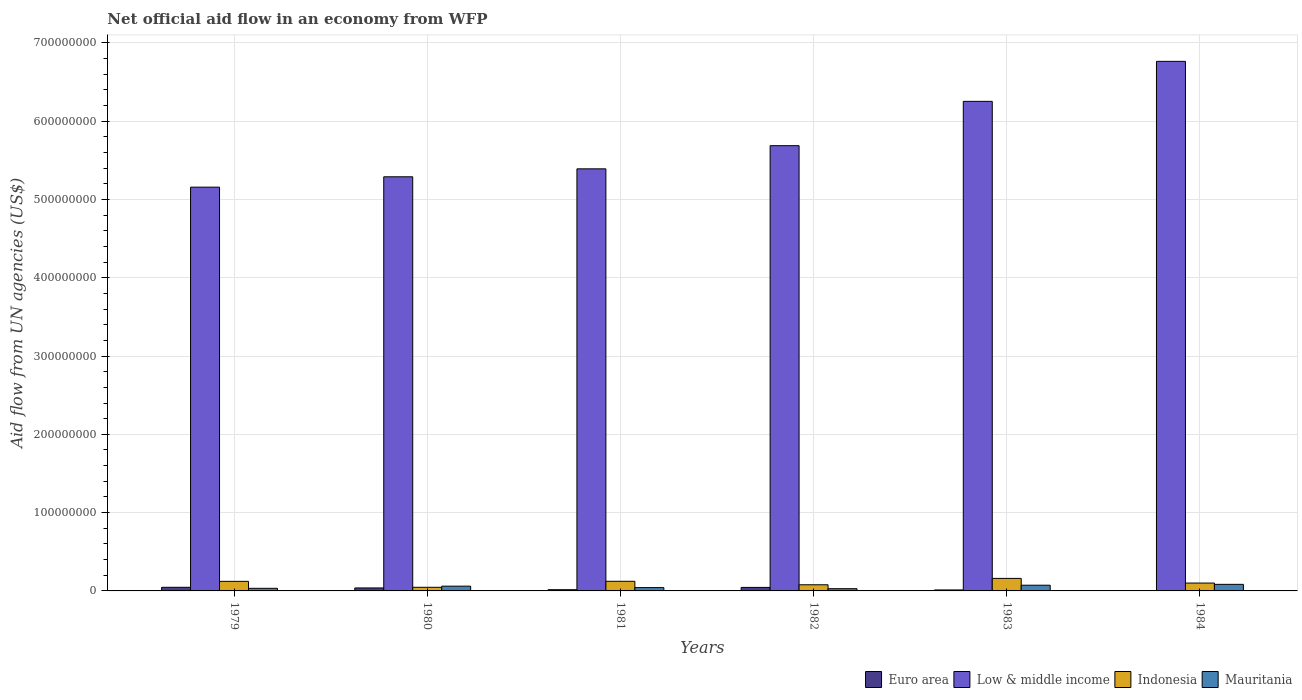How many different coloured bars are there?
Provide a short and direct response. 4. How many groups of bars are there?
Provide a short and direct response. 6. Are the number of bars per tick equal to the number of legend labels?
Keep it short and to the point. Yes. Are the number of bars on each tick of the X-axis equal?
Your answer should be compact. Yes. What is the net official aid flow in Mauritania in 1982?
Ensure brevity in your answer.  2.84e+06. Across all years, what is the maximum net official aid flow in Mauritania?
Give a very brief answer. 8.39e+06. Across all years, what is the minimum net official aid flow in Indonesia?
Keep it short and to the point. 4.63e+06. In which year was the net official aid flow in Euro area minimum?
Make the answer very short. 1984. What is the total net official aid flow in Indonesia in the graph?
Offer a terse response. 6.30e+07. What is the difference between the net official aid flow in Low & middle income in 1979 and that in 1982?
Offer a very short reply. -5.30e+07. What is the difference between the net official aid flow in Euro area in 1979 and the net official aid flow in Mauritania in 1984?
Give a very brief answer. -3.77e+06. What is the average net official aid flow in Euro area per year?
Provide a short and direct response. 2.65e+06. In the year 1983, what is the difference between the net official aid flow in Mauritania and net official aid flow in Low & middle income?
Ensure brevity in your answer.  -6.18e+08. What is the ratio of the net official aid flow in Euro area in 1980 to that in 1982?
Keep it short and to the point. 0.85. Is the net official aid flow in Low & middle income in 1981 less than that in 1982?
Keep it short and to the point. Yes. Is the difference between the net official aid flow in Mauritania in 1979 and 1983 greater than the difference between the net official aid flow in Low & middle income in 1979 and 1983?
Your answer should be very brief. Yes. What is the difference between the highest and the second highest net official aid flow in Indonesia?
Give a very brief answer. 3.68e+06. What is the difference between the highest and the lowest net official aid flow in Mauritania?
Make the answer very short. 5.55e+06. Is the sum of the net official aid flow in Low & middle income in 1979 and 1981 greater than the maximum net official aid flow in Indonesia across all years?
Provide a succinct answer. Yes. Is it the case that in every year, the sum of the net official aid flow in Indonesia and net official aid flow in Mauritania is greater than the sum of net official aid flow in Low & middle income and net official aid flow in Euro area?
Offer a very short reply. No. What does the 4th bar from the right in 1983 represents?
Give a very brief answer. Euro area. Is it the case that in every year, the sum of the net official aid flow in Low & middle income and net official aid flow in Mauritania is greater than the net official aid flow in Euro area?
Offer a terse response. Yes. Are the values on the major ticks of Y-axis written in scientific E-notation?
Ensure brevity in your answer.  No. How many legend labels are there?
Your answer should be very brief. 4. What is the title of the graph?
Keep it short and to the point. Net official aid flow in an economy from WFP. Does "Saudi Arabia" appear as one of the legend labels in the graph?
Offer a very short reply. No. What is the label or title of the X-axis?
Make the answer very short. Years. What is the label or title of the Y-axis?
Provide a short and direct response. Aid flow from UN agencies (US$). What is the Aid flow from UN agencies (US$) of Euro area in 1979?
Your response must be concise. 4.62e+06. What is the Aid flow from UN agencies (US$) in Low & middle income in 1979?
Offer a terse response. 5.16e+08. What is the Aid flow from UN agencies (US$) of Indonesia in 1979?
Make the answer very short. 1.22e+07. What is the Aid flow from UN agencies (US$) of Mauritania in 1979?
Keep it short and to the point. 3.33e+06. What is the Aid flow from UN agencies (US$) of Euro area in 1980?
Ensure brevity in your answer.  3.80e+06. What is the Aid flow from UN agencies (US$) of Low & middle income in 1980?
Keep it short and to the point. 5.29e+08. What is the Aid flow from UN agencies (US$) in Indonesia in 1980?
Offer a terse response. 4.63e+06. What is the Aid flow from UN agencies (US$) of Mauritania in 1980?
Provide a succinct answer. 6.08e+06. What is the Aid flow from UN agencies (US$) of Euro area in 1981?
Make the answer very short. 1.54e+06. What is the Aid flow from UN agencies (US$) in Low & middle income in 1981?
Offer a very short reply. 5.39e+08. What is the Aid flow from UN agencies (US$) in Indonesia in 1981?
Your response must be concise. 1.23e+07. What is the Aid flow from UN agencies (US$) in Mauritania in 1981?
Make the answer very short. 4.24e+06. What is the Aid flow from UN agencies (US$) of Euro area in 1982?
Keep it short and to the point. 4.49e+06. What is the Aid flow from UN agencies (US$) in Low & middle income in 1982?
Keep it short and to the point. 5.69e+08. What is the Aid flow from UN agencies (US$) of Indonesia in 1982?
Ensure brevity in your answer.  7.85e+06. What is the Aid flow from UN agencies (US$) in Mauritania in 1982?
Make the answer very short. 2.84e+06. What is the Aid flow from UN agencies (US$) of Euro area in 1983?
Your answer should be compact. 1.25e+06. What is the Aid flow from UN agencies (US$) in Low & middle income in 1983?
Give a very brief answer. 6.25e+08. What is the Aid flow from UN agencies (US$) in Indonesia in 1983?
Offer a terse response. 1.60e+07. What is the Aid flow from UN agencies (US$) in Mauritania in 1983?
Your answer should be very brief. 7.30e+06. What is the Aid flow from UN agencies (US$) of Low & middle income in 1984?
Offer a very short reply. 6.76e+08. What is the Aid flow from UN agencies (US$) in Indonesia in 1984?
Offer a very short reply. 1.00e+07. What is the Aid flow from UN agencies (US$) in Mauritania in 1984?
Your response must be concise. 8.39e+06. Across all years, what is the maximum Aid flow from UN agencies (US$) of Euro area?
Your answer should be very brief. 4.62e+06. Across all years, what is the maximum Aid flow from UN agencies (US$) in Low & middle income?
Keep it short and to the point. 6.76e+08. Across all years, what is the maximum Aid flow from UN agencies (US$) of Indonesia?
Your answer should be very brief. 1.60e+07. Across all years, what is the maximum Aid flow from UN agencies (US$) of Mauritania?
Ensure brevity in your answer.  8.39e+06. Across all years, what is the minimum Aid flow from UN agencies (US$) in Low & middle income?
Make the answer very short. 5.16e+08. Across all years, what is the minimum Aid flow from UN agencies (US$) in Indonesia?
Your answer should be very brief. 4.63e+06. Across all years, what is the minimum Aid flow from UN agencies (US$) in Mauritania?
Provide a short and direct response. 2.84e+06. What is the total Aid flow from UN agencies (US$) of Euro area in the graph?
Provide a succinct answer. 1.59e+07. What is the total Aid flow from UN agencies (US$) of Low & middle income in the graph?
Your answer should be very brief. 3.45e+09. What is the total Aid flow from UN agencies (US$) in Indonesia in the graph?
Your response must be concise. 6.30e+07. What is the total Aid flow from UN agencies (US$) in Mauritania in the graph?
Ensure brevity in your answer.  3.22e+07. What is the difference between the Aid flow from UN agencies (US$) in Euro area in 1979 and that in 1980?
Keep it short and to the point. 8.20e+05. What is the difference between the Aid flow from UN agencies (US$) of Low & middle income in 1979 and that in 1980?
Your response must be concise. -1.32e+07. What is the difference between the Aid flow from UN agencies (US$) of Indonesia in 1979 and that in 1980?
Your response must be concise. 7.59e+06. What is the difference between the Aid flow from UN agencies (US$) in Mauritania in 1979 and that in 1980?
Offer a very short reply. -2.75e+06. What is the difference between the Aid flow from UN agencies (US$) in Euro area in 1979 and that in 1981?
Your answer should be very brief. 3.08e+06. What is the difference between the Aid flow from UN agencies (US$) in Low & middle income in 1979 and that in 1981?
Make the answer very short. -2.34e+07. What is the difference between the Aid flow from UN agencies (US$) in Indonesia in 1979 and that in 1981?
Give a very brief answer. -9.00e+04. What is the difference between the Aid flow from UN agencies (US$) in Mauritania in 1979 and that in 1981?
Provide a succinct answer. -9.10e+05. What is the difference between the Aid flow from UN agencies (US$) of Euro area in 1979 and that in 1982?
Ensure brevity in your answer.  1.30e+05. What is the difference between the Aid flow from UN agencies (US$) of Low & middle income in 1979 and that in 1982?
Your answer should be very brief. -5.30e+07. What is the difference between the Aid flow from UN agencies (US$) of Indonesia in 1979 and that in 1982?
Make the answer very short. 4.37e+06. What is the difference between the Aid flow from UN agencies (US$) of Mauritania in 1979 and that in 1982?
Offer a very short reply. 4.90e+05. What is the difference between the Aid flow from UN agencies (US$) of Euro area in 1979 and that in 1983?
Your answer should be very brief. 3.37e+06. What is the difference between the Aid flow from UN agencies (US$) in Low & middle income in 1979 and that in 1983?
Ensure brevity in your answer.  -1.10e+08. What is the difference between the Aid flow from UN agencies (US$) of Indonesia in 1979 and that in 1983?
Your answer should be very brief. -3.77e+06. What is the difference between the Aid flow from UN agencies (US$) in Mauritania in 1979 and that in 1983?
Provide a succinct answer. -3.97e+06. What is the difference between the Aid flow from UN agencies (US$) in Euro area in 1979 and that in 1984?
Provide a short and direct response. 4.40e+06. What is the difference between the Aid flow from UN agencies (US$) in Low & middle income in 1979 and that in 1984?
Your answer should be very brief. -1.61e+08. What is the difference between the Aid flow from UN agencies (US$) in Indonesia in 1979 and that in 1984?
Give a very brief answer. 2.17e+06. What is the difference between the Aid flow from UN agencies (US$) in Mauritania in 1979 and that in 1984?
Ensure brevity in your answer.  -5.06e+06. What is the difference between the Aid flow from UN agencies (US$) in Euro area in 1980 and that in 1981?
Keep it short and to the point. 2.26e+06. What is the difference between the Aid flow from UN agencies (US$) of Low & middle income in 1980 and that in 1981?
Give a very brief answer. -1.02e+07. What is the difference between the Aid flow from UN agencies (US$) of Indonesia in 1980 and that in 1981?
Ensure brevity in your answer.  -7.68e+06. What is the difference between the Aid flow from UN agencies (US$) of Mauritania in 1980 and that in 1981?
Your answer should be very brief. 1.84e+06. What is the difference between the Aid flow from UN agencies (US$) in Euro area in 1980 and that in 1982?
Offer a very short reply. -6.90e+05. What is the difference between the Aid flow from UN agencies (US$) in Low & middle income in 1980 and that in 1982?
Give a very brief answer. -3.97e+07. What is the difference between the Aid flow from UN agencies (US$) of Indonesia in 1980 and that in 1982?
Your response must be concise. -3.22e+06. What is the difference between the Aid flow from UN agencies (US$) of Mauritania in 1980 and that in 1982?
Ensure brevity in your answer.  3.24e+06. What is the difference between the Aid flow from UN agencies (US$) in Euro area in 1980 and that in 1983?
Make the answer very short. 2.55e+06. What is the difference between the Aid flow from UN agencies (US$) in Low & middle income in 1980 and that in 1983?
Your response must be concise. -9.63e+07. What is the difference between the Aid flow from UN agencies (US$) in Indonesia in 1980 and that in 1983?
Offer a very short reply. -1.14e+07. What is the difference between the Aid flow from UN agencies (US$) in Mauritania in 1980 and that in 1983?
Ensure brevity in your answer.  -1.22e+06. What is the difference between the Aid flow from UN agencies (US$) of Euro area in 1980 and that in 1984?
Ensure brevity in your answer.  3.58e+06. What is the difference between the Aid flow from UN agencies (US$) of Low & middle income in 1980 and that in 1984?
Your answer should be very brief. -1.47e+08. What is the difference between the Aid flow from UN agencies (US$) of Indonesia in 1980 and that in 1984?
Your answer should be compact. -5.42e+06. What is the difference between the Aid flow from UN agencies (US$) in Mauritania in 1980 and that in 1984?
Offer a very short reply. -2.31e+06. What is the difference between the Aid flow from UN agencies (US$) in Euro area in 1981 and that in 1982?
Keep it short and to the point. -2.95e+06. What is the difference between the Aid flow from UN agencies (US$) of Low & middle income in 1981 and that in 1982?
Keep it short and to the point. -2.96e+07. What is the difference between the Aid flow from UN agencies (US$) of Indonesia in 1981 and that in 1982?
Your answer should be compact. 4.46e+06. What is the difference between the Aid flow from UN agencies (US$) of Mauritania in 1981 and that in 1982?
Provide a short and direct response. 1.40e+06. What is the difference between the Aid flow from UN agencies (US$) in Euro area in 1981 and that in 1983?
Your answer should be very brief. 2.90e+05. What is the difference between the Aid flow from UN agencies (US$) in Low & middle income in 1981 and that in 1983?
Give a very brief answer. -8.62e+07. What is the difference between the Aid flow from UN agencies (US$) of Indonesia in 1981 and that in 1983?
Ensure brevity in your answer.  -3.68e+06. What is the difference between the Aid flow from UN agencies (US$) of Mauritania in 1981 and that in 1983?
Your response must be concise. -3.06e+06. What is the difference between the Aid flow from UN agencies (US$) in Euro area in 1981 and that in 1984?
Your answer should be very brief. 1.32e+06. What is the difference between the Aid flow from UN agencies (US$) in Low & middle income in 1981 and that in 1984?
Offer a terse response. -1.37e+08. What is the difference between the Aid flow from UN agencies (US$) in Indonesia in 1981 and that in 1984?
Your answer should be very brief. 2.26e+06. What is the difference between the Aid flow from UN agencies (US$) in Mauritania in 1981 and that in 1984?
Your response must be concise. -4.15e+06. What is the difference between the Aid flow from UN agencies (US$) of Euro area in 1982 and that in 1983?
Ensure brevity in your answer.  3.24e+06. What is the difference between the Aid flow from UN agencies (US$) of Low & middle income in 1982 and that in 1983?
Your answer should be very brief. -5.66e+07. What is the difference between the Aid flow from UN agencies (US$) in Indonesia in 1982 and that in 1983?
Provide a succinct answer. -8.14e+06. What is the difference between the Aid flow from UN agencies (US$) of Mauritania in 1982 and that in 1983?
Offer a very short reply. -4.46e+06. What is the difference between the Aid flow from UN agencies (US$) in Euro area in 1982 and that in 1984?
Give a very brief answer. 4.27e+06. What is the difference between the Aid flow from UN agencies (US$) of Low & middle income in 1982 and that in 1984?
Your answer should be very brief. -1.08e+08. What is the difference between the Aid flow from UN agencies (US$) in Indonesia in 1982 and that in 1984?
Keep it short and to the point. -2.20e+06. What is the difference between the Aid flow from UN agencies (US$) in Mauritania in 1982 and that in 1984?
Give a very brief answer. -5.55e+06. What is the difference between the Aid flow from UN agencies (US$) of Euro area in 1983 and that in 1984?
Your answer should be compact. 1.03e+06. What is the difference between the Aid flow from UN agencies (US$) of Low & middle income in 1983 and that in 1984?
Your answer should be compact. -5.11e+07. What is the difference between the Aid flow from UN agencies (US$) of Indonesia in 1983 and that in 1984?
Offer a very short reply. 5.94e+06. What is the difference between the Aid flow from UN agencies (US$) of Mauritania in 1983 and that in 1984?
Provide a succinct answer. -1.09e+06. What is the difference between the Aid flow from UN agencies (US$) in Euro area in 1979 and the Aid flow from UN agencies (US$) in Low & middle income in 1980?
Give a very brief answer. -5.24e+08. What is the difference between the Aid flow from UN agencies (US$) of Euro area in 1979 and the Aid flow from UN agencies (US$) of Indonesia in 1980?
Your answer should be very brief. -10000. What is the difference between the Aid flow from UN agencies (US$) in Euro area in 1979 and the Aid flow from UN agencies (US$) in Mauritania in 1980?
Ensure brevity in your answer.  -1.46e+06. What is the difference between the Aid flow from UN agencies (US$) of Low & middle income in 1979 and the Aid flow from UN agencies (US$) of Indonesia in 1980?
Give a very brief answer. 5.11e+08. What is the difference between the Aid flow from UN agencies (US$) of Low & middle income in 1979 and the Aid flow from UN agencies (US$) of Mauritania in 1980?
Your answer should be compact. 5.10e+08. What is the difference between the Aid flow from UN agencies (US$) in Indonesia in 1979 and the Aid flow from UN agencies (US$) in Mauritania in 1980?
Your answer should be very brief. 6.14e+06. What is the difference between the Aid flow from UN agencies (US$) of Euro area in 1979 and the Aid flow from UN agencies (US$) of Low & middle income in 1981?
Ensure brevity in your answer.  -5.34e+08. What is the difference between the Aid flow from UN agencies (US$) in Euro area in 1979 and the Aid flow from UN agencies (US$) in Indonesia in 1981?
Provide a succinct answer. -7.69e+06. What is the difference between the Aid flow from UN agencies (US$) in Euro area in 1979 and the Aid flow from UN agencies (US$) in Mauritania in 1981?
Provide a succinct answer. 3.80e+05. What is the difference between the Aid flow from UN agencies (US$) of Low & middle income in 1979 and the Aid flow from UN agencies (US$) of Indonesia in 1981?
Provide a short and direct response. 5.03e+08. What is the difference between the Aid flow from UN agencies (US$) in Low & middle income in 1979 and the Aid flow from UN agencies (US$) in Mauritania in 1981?
Your answer should be very brief. 5.11e+08. What is the difference between the Aid flow from UN agencies (US$) in Indonesia in 1979 and the Aid flow from UN agencies (US$) in Mauritania in 1981?
Your answer should be very brief. 7.98e+06. What is the difference between the Aid flow from UN agencies (US$) of Euro area in 1979 and the Aid flow from UN agencies (US$) of Low & middle income in 1982?
Keep it short and to the point. -5.64e+08. What is the difference between the Aid flow from UN agencies (US$) in Euro area in 1979 and the Aid flow from UN agencies (US$) in Indonesia in 1982?
Your answer should be very brief. -3.23e+06. What is the difference between the Aid flow from UN agencies (US$) in Euro area in 1979 and the Aid flow from UN agencies (US$) in Mauritania in 1982?
Your answer should be compact. 1.78e+06. What is the difference between the Aid flow from UN agencies (US$) in Low & middle income in 1979 and the Aid flow from UN agencies (US$) in Indonesia in 1982?
Give a very brief answer. 5.08e+08. What is the difference between the Aid flow from UN agencies (US$) in Low & middle income in 1979 and the Aid flow from UN agencies (US$) in Mauritania in 1982?
Ensure brevity in your answer.  5.13e+08. What is the difference between the Aid flow from UN agencies (US$) in Indonesia in 1979 and the Aid flow from UN agencies (US$) in Mauritania in 1982?
Give a very brief answer. 9.38e+06. What is the difference between the Aid flow from UN agencies (US$) of Euro area in 1979 and the Aid flow from UN agencies (US$) of Low & middle income in 1983?
Keep it short and to the point. -6.21e+08. What is the difference between the Aid flow from UN agencies (US$) in Euro area in 1979 and the Aid flow from UN agencies (US$) in Indonesia in 1983?
Your answer should be compact. -1.14e+07. What is the difference between the Aid flow from UN agencies (US$) in Euro area in 1979 and the Aid flow from UN agencies (US$) in Mauritania in 1983?
Keep it short and to the point. -2.68e+06. What is the difference between the Aid flow from UN agencies (US$) of Low & middle income in 1979 and the Aid flow from UN agencies (US$) of Indonesia in 1983?
Provide a short and direct response. 5.00e+08. What is the difference between the Aid flow from UN agencies (US$) in Low & middle income in 1979 and the Aid flow from UN agencies (US$) in Mauritania in 1983?
Offer a terse response. 5.08e+08. What is the difference between the Aid flow from UN agencies (US$) of Indonesia in 1979 and the Aid flow from UN agencies (US$) of Mauritania in 1983?
Provide a succinct answer. 4.92e+06. What is the difference between the Aid flow from UN agencies (US$) in Euro area in 1979 and the Aid flow from UN agencies (US$) in Low & middle income in 1984?
Ensure brevity in your answer.  -6.72e+08. What is the difference between the Aid flow from UN agencies (US$) of Euro area in 1979 and the Aid flow from UN agencies (US$) of Indonesia in 1984?
Your answer should be compact. -5.43e+06. What is the difference between the Aid flow from UN agencies (US$) in Euro area in 1979 and the Aid flow from UN agencies (US$) in Mauritania in 1984?
Your answer should be very brief. -3.77e+06. What is the difference between the Aid flow from UN agencies (US$) in Low & middle income in 1979 and the Aid flow from UN agencies (US$) in Indonesia in 1984?
Your response must be concise. 5.06e+08. What is the difference between the Aid flow from UN agencies (US$) of Low & middle income in 1979 and the Aid flow from UN agencies (US$) of Mauritania in 1984?
Ensure brevity in your answer.  5.07e+08. What is the difference between the Aid flow from UN agencies (US$) of Indonesia in 1979 and the Aid flow from UN agencies (US$) of Mauritania in 1984?
Provide a short and direct response. 3.83e+06. What is the difference between the Aid flow from UN agencies (US$) in Euro area in 1980 and the Aid flow from UN agencies (US$) in Low & middle income in 1981?
Make the answer very short. -5.35e+08. What is the difference between the Aid flow from UN agencies (US$) in Euro area in 1980 and the Aid flow from UN agencies (US$) in Indonesia in 1981?
Give a very brief answer. -8.51e+06. What is the difference between the Aid flow from UN agencies (US$) of Euro area in 1980 and the Aid flow from UN agencies (US$) of Mauritania in 1981?
Give a very brief answer. -4.40e+05. What is the difference between the Aid flow from UN agencies (US$) of Low & middle income in 1980 and the Aid flow from UN agencies (US$) of Indonesia in 1981?
Offer a very short reply. 5.17e+08. What is the difference between the Aid flow from UN agencies (US$) of Low & middle income in 1980 and the Aid flow from UN agencies (US$) of Mauritania in 1981?
Make the answer very short. 5.25e+08. What is the difference between the Aid flow from UN agencies (US$) in Euro area in 1980 and the Aid flow from UN agencies (US$) in Low & middle income in 1982?
Your response must be concise. -5.65e+08. What is the difference between the Aid flow from UN agencies (US$) in Euro area in 1980 and the Aid flow from UN agencies (US$) in Indonesia in 1982?
Provide a succinct answer. -4.05e+06. What is the difference between the Aid flow from UN agencies (US$) in Euro area in 1980 and the Aid flow from UN agencies (US$) in Mauritania in 1982?
Provide a succinct answer. 9.60e+05. What is the difference between the Aid flow from UN agencies (US$) in Low & middle income in 1980 and the Aid flow from UN agencies (US$) in Indonesia in 1982?
Keep it short and to the point. 5.21e+08. What is the difference between the Aid flow from UN agencies (US$) in Low & middle income in 1980 and the Aid flow from UN agencies (US$) in Mauritania in 1982?
Ensure brevity in your answer.  5.26e+08. What is the difference between the Aid flow from UN agencies (US$) in Indonesia in 1980 and the Aid flow from UN agencies (US$) in Mauritania in 1982?
Make the answer very short. 1.79e+06. What is the difference between the Aid flow from UN agencies (US$) of Euro area in 1980 and the Aid flow from UN agencies (US$) of Low & middle income in 1983?
Your answer should be compact. -6.21e+08. What is the difference between the Aid flow from UN agencies (US$) in Euro area in 1980 and the Aid flow from UN agencies (US$) in Indonesia in 1983?
Your answer should be compact. -1.22e+07. What is the difference between the Aid flow from UN agencies (US$) in Euro area in 1980 and the Aid flow from UN agencies (US$) in Mauritania in 1983?
Give a very brief answer. -3.50e+06. What is the difference between the Aid flow from UN agencies (US$) of Low & middle income in 1980 and the Aid flow from UN agencies (US$) of Indonesia in 1983?
Make the answer very short. 5.13e+08. What is the difference between the Aid flow from UN agencies (US$) in Low & middle income in 1980 and the Aid flow from UN agencies (US$) in Mauritania in 1983?
Your response must be concise. 5.22e+08. What is the difference between the Aid flow from UN agencies (US$) in Indonesia in 1980 and the Aid flow from UN agencies (US$) in Mauritania in 1983?
Offer a terse response. -2.67e+06. What is the difference between the Aid flow from UN agencies (US$) of Euro area in 1980 and the Aid flow from UN agencies (US$) of Low & middle income in 1984?
Ensure brevity in your answer.  -6.73e+08. What is the difference between the Aid flow from UN agencies (US$) of Euro area in 1980 and the Aid flow from UN agencies (US$) of Indonesia in 1984?
Your answer should be compact. -6.25e+06. What is the difference between the Aid flow from UN agencies (US$) in Euro area in 1980 and the Aid flow from UN agencies (US$) in Mauritania in 1984?
Give a very brief answer. -4.59e+06. What is the difference between the Aid flow from UN agencies (US$) in Low & middle income in 1980 and the Aid flow from UN agencies (US$) in Indonesia in 1984?
Your answer should be compact. 5.19e+08. What is the difference between the Aid flow from UN agencies (US$) in Low & middle income in 1980 and the Aid flow from UN agencies (US$) in Mauritania in 1984?
Offer a very short reply. 5.21e+08. What is the difference between the Aid flow from UN agencies (US$) in Indonesia in 1980 and the Aid flow from UN agencies (US$) in Mauritania in 1984?
Give a very brief answer. -3.76e+06. What is the difference between the Aid flow from UN agencies (US$) of Euro area in 1981 and the Aid flow from UN agencies (US$) of Low & middle income in 1982?
Offer a terse response. -5.67e+08. What is the difference between the Aid flow from UN agencies (US$) of Euro area in 1981 and the Aid flow from UN agencies (US$) of Indonesia in 1982?
Offer a terse response. -6.31e+06. What is the difference between the Aid flow from UN agencies (US$) of Euro area in 1981 and the Aid flow from UN agencies (US$) of Mauritania in 1982?
Provide a succinct answer. -1.30e+06. What is the difference between the Aid flow from UN agencies (US$) of Low & middle income in 1981 and the Aid flow from UN agencies (US$) of Indonesia in 1982?
Give a very brief answer. 5.31e+08. What is the difference between the Aid flow from UN agencies (US$) of Low & middle income in 1981 and the Aid flow from UN agencies (US$) of Mauritania in 1982?
Keep it short and to the point. 5.36e+08. What is the difference between the Aid flow from UN agencies (US$) of Indonesia in 1981 and the Aid flow from UN agencies (US$) of Mauritania in 1982?
Offer a terse response. 9.47e+06. What is the difference between the Aid flow from UN agencies (US$) of Euro area in 1981 and the Aid flow from UN agencies (US$) of Low & middle income in 1983?
Make the answer very short. -6.24e+08. What is the difference between the Aid flow from UN agencies (US$) of Euro area in 1981 and the Aid flow from UN agencies (US$) of Indonesia in 1983?
Ensure brevity in your answer.  -1.44e+07. What is the difference between the Aid flow from UN agencies (US$) in Euro area in 1981 and the Aid flow from UN agencies (US$) in Mauritania in 1983?
Make the answer very short. -5.76e+06. What is the difference between the Aid flow from UN agencies (US$) of Low & middle income in 1981 and the Aid flow from UN agencies (US$) of Indonesia in 1983?
Your answer should be very brief. 5.23e+08. What is the difference between the Aid flow from UN agencies (US$) in Low & middle income in 1981 and the Aid flow from UN agencies (US$) in Mauritania in 1983?
Give a very brief answer. 5.32e+08. What is the difference between the Aid flow from UN agencies (US$) of Indonesia in 1981 and the Aid flow from UN agencies (US$) of Mauritania in 1983?
Keep it short and to the point. 5.01e+06. What is the difference between the Aid flow from UN agencies (US$) in Euro area in 1981 and the Aid flow from UN agencies (US$) in Low & middle income in 1984?
Keep it short and to the point. -6.75e+08. What is the difference between the Aid flow from UN agencies (US$) of Euro area in 1981 and the Aid flow from UN agencies (US$) of Indonesia in 1984?
Your answer should be compact. -8.51e+06. What is the difference between the Aid flow from UN agencies (US$) in Euro area in 1981 and the Aid flow from UN agencies (US$) in Mauritania in 1984?
Your answer should be compact. -6.85e+06. What is the difference between the Aid flow from UN agencies (US$) of Low & middle income in 1981 and the Aid flow from UN agencies (US$) of Indonesia in 1984?
Ensure brevity in your answer.  5.29e+08. What is the difference between the Aid flow from UN agencies (US$) of Low & middle income in 1981 and the Aid flow from UN agencies (US$) of Mauritania in 1984?
Your answer should be compact. 5.31e+08. What is the difference between the Aid flow from UN agencies (US$) of Indonesia in 1981 and the Aid flow from UN agencies (US$) of Mauritania in 1984?
Your answer should be very brief. 3.92e+06. What is the difference between the Aid flow from UN agencies (US$) of Euro area in 1982 and the Aid flow from UN agencies (US$) of Low & middle income in 1983?
Offer a terse response. -6.21e+08. What is the difference between the Aid flow from UN agencies (US$) of Euro area in 1982 and the Aid flow from UN agencies (US$) of Indonesia in 1983?
Keep it short and to the point. -1.15e+07. What is the difference between the Aid flow from UN agencies (US$) of Euro area in 1982 and the Aid flow from UN agencies (US$) of Mauritania in 1983?
Offer a very short reply. -2.81e+06. What is the difference between the Aid flow from UN agencies (US$) in Low & middle income in 1982 and the Aid flow from UN agencies (US$) in Indonesia in 1983?
Your response must be concise. 5.53e+08. What is the difference between the Aid flow from UN agencies (US$) of Low & middle income in 1982 and the Aid flow from UN agencies (US$) of Mauritania in 1983?
Your answer should be compact. 5.61e+08. What is the difference between the Aid flow from UN agencies (US$) in Indonesia in 1982 and the Aid flow from UN agencies (US$) in Mauritania in 1983?
Your answer should be very brief. 5.50e+05. What is the difference between the Aid flow from UN agencies (US$) in Euro area in 1982 and the Aid flow from UN agencies (US$) in Low & middle income in 1984?
Give a very brief answer. -6.72e+08. What is the difference between the Aid flow from UN agencies (US$) of Euro area in 1982 and the Aid flow from UN agencies (US$) of Indonesia in 1984?
Give a very brief answer. -5.56e+06. What is the difference between the Aid flow from UN agencies (US$) in Euro area in 1982 and the Aid flow from UN agencies (US$) in Mauritania in 1984?
Offer a terse response. -3.90e+06. What is the difference between the Aid flow from UN agencies (US$) of Low & middle income in 1982 and the Aid flow from UN agencies (US$) of Indonesia in 1984?
Your response must be concise. 5.59e+08. What is the difference between the Aid flow from UN agencies (US$) of Low & middle income in 1982 and the Aid flow from UN agencies (US$) of Mauritania in 1984?
Make the answer very short. 5.60e+08. What is the difference between the Aid flow from UN agencies (US$) in Indonesia in 1982 and the Aid flow from UN agencies (US$) in Mauritania in 1984?
Keep it short and to the point. -5.40e+05. What is the difference between the Aid flow from UN agencies (US$) of Euro area in 1983 and the Aid flow from UN agencies (US$) of Low & middle income in 1984?
Offer a terse response. -6.75e+08. What is the difference between the Aid flow from UN agencies (US$) of Euro area in 1983 and the Aid flow from UN agencies (US$) of Indonesia in 1984?
Your answer should be very brief. -8.80e+06. What is the difference between the Aid flow from UN agencies (US$) of Euro area in 1983 and the Aid flow from UN agencies (US$) of Mauritania in 1984?
Keep it short and to the point. -7.14e+06. What is the difference between the Aid flow from UN agencies (US$) of Low & middle income in 1983 and the Aid flow from UN agencies (US$) of Indonesia in 1984?
Your response must be concise. 6.15e+08. What is the difference between the Aid flow from UN agencies (US$) of Low & middle income in 1983 and the Aid flow from UN agencies (US$) of Mauritania in 1984?
Offer a very short reply. 6.17e+08. What is the difference between the Aid flow from UN agencies (US$) of Indonesia in 1983 and the Aid flow from UN agencies (US$) of Mauritania in 1984?
Your response must be concise. 7.60e+06. What is the average Aid flow from UN agencies (US$) of Euro area per year?
Your response must be concise. 2.65e+06. What is the average Aid flow from UN agencies (US$) of Low & middle income per year?
Make the answer very short. 5.76e+08. What is the average Aid flow from UN agencies (US$) in Indonesia per year?
Make the answer very short. 1.05e+07. What is the average Aid flow from UN agencies (US$) in Mauritania per year?
Make the answer very short. 5.36e+06. In the year 1979, what is the difference between the Aid flow from UN agencies (US$) of Euro area and Aid flow from UN agencies (US$) of Low & middle income?
Make the answer very short. -5.11e+08. In the year 1979, what is the difference between the Aid flow from UN agencies (US$) of Euro area and Aid flow from UN agencies (US$) of Indonesia?
Your response must be concise. -7.60e+06. In the year 1979, what is the difference between the Aid flow from UN agencies (US$) of Euro area and Aid flow from UN agencies (US$) of Mauritania?
Provide a succinct answer. 1.29e+06. In the year 1979, what is the difference between the Aid flow from UN agencies (US$) in Low & middle income and Aid flow from UN agencies (US$) in Indonesia?
Offer a very short reply. 5.03e+08. In the year 1979, what is the difference between the Aid flow from UN agencies (US$) of Low & middle income and Aid flow from UN agencies (US$) of Mauritania?
Keep it short and to the point. 5.12e+08. In the year 1979, what is the difference between the Aid flow from UN agencies (US$) in Indonesia and Aid flow from UN agencies (US$) in Mauritania?
Make the answer very short. 8.89e+06. In the year 1980, what is the difference between the Aid flow from UN agencies (US$) in Euro area and Aid flow from UN agencies (US$) in Low & middle income?
Ensure brevity in your answer.  -5.25e+08. In the year 1980, what is the difference between the Aid flow from UN agencies (US$) of Euro area and Aid flow from UN agencies (US$) of Indonesia?
Provide a short and direct response. -8.30e+05. In the year 1980, what is the difference between the Aid flow from UN agencies (US$) of Euro area and Aid flow from UN agencies (US$) of Mauritania?
Offer a very short reply. -2.28e+06. In the year 1980, what is the difference between the Aid flow from UN agencies (US$) of Low & middle income and Aid flow from UN agencies (US$) of Indonesia?
Provide a short and direct response. 5.24e+08. In the year 1980, what is the difference between the Aid flow from UN agencies (US$) in Low & middle income and Aid flow from UN agencies (US$) in Mauritania?
Ensure brevity in your answer.  5.23e+08. In the year 1980, what is the difference between the Aid flow from UN agencies (US$) in Indonesia and Aid flow from UN agencies (US$) in Mauritania?
Your answer should be very brief. -1.45e+06. In the year 1981, what is the difference between the Aid flow from UN agencies (US$) in Euro area and Aid flow from UN agencies (US$) in Low & middle income?
Provide a short and direct response. -5.38e+08. In the year 1981, what is the difference between the Aid flow from UN agencies (US$) of Euro area and Aid flow from UN agencies (US$) of Indonesia?
Keep it short and to the point. -1.08e+07. In the year 1981, what is the difference between the Aid flow from UN agencies (US$) of Euro area and Aid flow from UN agencies (US$) of Mauritania?
Provide a short and direct response. -2.70e+06. In the year 1981, what is the difference between the Aid flow from UN agencies (US$) of Low & middle income and Aid flow from UN agencies (US$) of Indonesia?
Make the answer very short. 5.27e+08. In the year 1981, what is the difference between the Aid flow from UN agencies (US$) in Low & middle income and Aid flow from UN agencies (US$) in Mauritania?
Your answer should be compact. 5.35e+08. In the year 1981, what is the difference between the Aid flow from UN agencies (US$) of Indonesia and Aid flow from UN agencies (US$) of Mauritania?
Give a very brief answer. 8.07e+06. In the year 1982, what is the difference between the Aid flow from UN agencies (US$) in Euro area and Aid flow from UN agencies (US$) in Low & middle income?
Your answer should be compact. -5.64e+08. In the year 1982, what is the difference between the Aid flow from UN agencies (US$) in Euro area and Aid flow from UN agencies (US$) in Indonesia?
Make the answer very short. -3.36e+06. In the year 1982, what is the difference between the Aid flow from UN agencies (US$) of Euro area and Aid flow from UN agencies (US$) of Mauritania?
Provide a short and direct response. 1.65e+06. In the year 1982, what is the difference between the Aid flow from UN agencies (US$) of Low & middle income and Aid flow from UN agencies (US$) of Indonesia?
Give a very brief answer. 5.61e+08. In the year 1982, what is the difference between the Aid flow from UN agencies (US$) of Low & middle income and Aid flow from UN agencies (US$) of Mauritania?
Your answer should be very brief. 5.66e+08. In the year 1982, what is the difference between the Aid flow from UN agencies (US$) of Indonesia and Aid flow from UN agencies (US$) of Mauritania?
Provide a succinct answer. 5.01e+06. In the year 1983, what is the difference between the Aid flow from UN agencies (US$) of Euro area and Aid flow from UN agencies (US$) of Low & middle income?
Your answer should be compact. -6.24e+08. In the year 1983, what is the difference between the Aid flow from UN agencies (US$) of Euro area and Aid flow from UN agencies (US$) of Indonesia?
Your answer should be compact. -1.47e+07. In the year 1983, what is the difference between the Aid flow from UN agencies (US$) in Euro area and Aid flow from UN agencies (US$) in Mauritania?
Make the answer very short. -6.05e+06. In the year 1983, what is the difference between the Aid flow from UN agencies (US$) in Low & middle income and Aid flow from UN agencies (US$) in Indonesia?
Your answer should be compact. 6.09e+08. In the year 1983, what is the difference between the Aid flow from UN agencies (US$) in Low & middle income and Aid flow from UN agencies (US$) in Mauritania?
Make the answer very short. 6.18e+08. In the year 1983, what is the difference between the Aid flow from UN agencies (US$) in Indonesia and Aid flow from UN agencies (US$) in Mauritania?
Your response must be concise. 8.69e+06. In the year 1984, what is the difference between the Aid flow from UN agencies (US$) of Euro area and Aid flow from UN agencies (US$) of Low & middle income?
Ensure brevity in your answer.  -6.76e+08. In the year 1984, what is the difference between the Aid flow from UN agencies (US$) of Euro area and Aid flow from UN agencies (US$) of Indonesia?
Provide a succinct answer. -9.83e+06. In the year 1984, what is the difference between the Aid flow from UN agencies (US$) of Euro area and Aid flow from UN agencies (US$) of Mauritania?
Provide a short and direct response. -8.17e+06. In the year 1984, what is the difference between the Aid flow from UN agencies (US$) in Low & middle income and Aid flow from UN agencies (US$) in Indonesia?
Your answer should be very brief. 6.66e+08. In the year 1984, what is the difference between the Aid flow from UN agencies (US$) of Low & middle income and Aid flow from UN agencies (US$) of Mauritania?
Offer a terse response. 6.68e+08. In the year 1984, what is the difference between the Aid flow from UN agencies (US$) of Indonesia and Aid flow from UN agencies (US$) of Mauritania?
Your response must be concise. 1.66e+06. What is the ratio of the Aid flow from UN agencies (US$) in Euro area in 1979 to that in 1980?
Provide a short and direct response. 1.22. What is the ratio of the Aid flow from UN agencies (US$) in Low & middle income in 1979 to that in 1980?
Your response must be concise. 0.97. What is the ratio of the Aid flow from UN agencies (US$) of Indonesia in 1979 to that in 1980?
Provide a short and direct response. 2.64. What is the ratio of the Aid flow from UN agencies (US$) of Mauritania in 1979 to that in 1980?
Provide a succinct answer. 0.55. What is the ratio of the Aid flow from UN agencies (US$) in Euro area in 1979 to that in 1981?
Keep it short and to the point. 3. What is the ratio of the Aid flow from UN agencies (US$) in Low & middle income in 1979 to that in 1981?
Give a very brief answer. 0.96. What is the ratio of the Aid flow from UN agencies (US$) in Mauritania in 1979 to that in 1981?
Your answer should be compact. 0.79. What is the ratio of the Aid flow from UN agencies (US$) of Low & middle income in 1979 to that in 1982?
Provide a succinct answer. 0.91. What is the ratio of the Aid flow from UN agencies (US$) of Indonesia in 1979 to that in 1982?
Your answer should be very brief. 1.56. What is the ratio of the Aid flow from UN agencies (US$) of Mauritania in 1979 to that in 1982?
Offer a very short reply. 1.17. What is the ratio of the Aid flow from UN agencies (US$) in Euro area in 1979 to that in 1983?
Give a very brief answer. 3.7. What is the ratio of the Aid flow from UN agencies (US$) in Low & middle income in 1979 to that in 1983?
Offer a very short reply. 0.82. What is the ratio of the Aid flow from UN agencies (US$) of Indonesia in 1979 to that in 1983?
Offer a terse response. 0.76. What is the ratio of the Aid flow from UN agencies (US$) of Mauritania in 1979 to that in 1983?
Give a very brief answer. 0.46. What is the ratio of the Aid flow from UN agencies (US$) of Euro area in 1979 to that in 1984?
Your answer should be very brief. 21. What is the ratio of the Aid flow from UN agencies (US$) of Low & middle income in 1979 to that in 1984?
Your answer should be very brief. 0.76. What is the ratio of the Aid flow from UN agencies (US$) in Indonesia in 1979 to that in 1984?
Your response must be concise. 1.22. What is the ratio of the Aid flow from UN agencies (US$) in Mauritania in 1979 to that in 1984?
Offer a terse response. 0.4. What is the ratio of the Aid flow from UN agencies (US$) of Euro area in 1980 to that in 1981?
Provide a succinct answer. 2.47. What is the ratio of the Aid flow from UN agencies (US$) in Low & middle income in 1980 to that in 1981?
Offer a terse response. 0.98. What is the ratio of the Aid flow from UN agencies (US$) of Indonesia in 1980 to that in 1981?
Ensure brevity in your answer.  0.38. What is the ratio of the Aid flow from UN agencies (US$) in Mauritania in 1980 to that in 1981?
Offer a terse response. 1.43. What is the ratio of the Aid flow from UN agencies (US$) in Euro area in 1980 to that in 1982?
Offer a terse response. 0.85. What is the ratio of the Aid flow from UN agencies (US$) in Low & middle income in 1980 to that in 1982?
Ensure brevity in your answer.  0.93. What is the ratio of the Aid flow from UN agencies (US$) of Indonesia in 1980 to that in 1982?
Offer a very short reply. 0.59. What is the ratio of the Aid flow from UN agencies (US$) in Mauritania in 1980 to that in 1982?
Ensure brevity in your answer.  2.14. What is the ratio of the Aid flow from UN agencies (US$) of Euro area in 1980 to that in 1983?
Give a very brief answer. 3.04. What is the ratio of the Aid flow from UN agencies (US$) in Low & middle income in 1980 to that in 1983?
Your response must be concise. 0.85. What is the ratio of the Aid flow from UN agencies (US$) in Indonesia in 1980 to that in 1983?
Your answer should be compact. 0.29. What is the ratio of the Aid flow from UN agencies (US$) of Mauritania in 1980 to that in 1983?
Offer a terse response. 0.83. What is the ratio of the Aid flow from UN agencies (US$) of Euro area in 1980 to that in 1984?
Your answer should be compact. 17.27. What is the ratio of the Aid flow from UN agencies (US$) in Low & middle income in 1980 to that in 1984?
Your answer should be compact. 0.78. What is the ratio of the Aid flow from UN agencies (US$) in Indonesia in 1980 to that in 1984?
Your answer should be very brief. 0.46. What is the ratio of the Aid flow from UN agencies (US$) in Mauritania in 1980 to that in 1984?
Offer a very short reply. 0.72. What is the ratio of the Aid flow from UN agencies (US$) in Euro area in 1981 to that in 1982?
Offer a very short reply. 0.34. What is the ratio of the Aid flow from UN agencies (US$) of Low & middle income in 1981 to that in 1982?
Keep it short and to the point. 0.95. What is the ratio of the Aid flow from UN agencies (US$) of Indonesia in 1981 to that in 1982?
Give a very brief answer. 1.57. What is the ratio of the Aid flow from UN agencies (US$) in Mauritania in 1981 to that in 1982?
Offer a very short reply. 1.49. What is the ratio of the Aid flow from UN agencies (US$) in Euro area in 1981 to that in 1983?
Your answer should be compact. 1.23. What is the ratio of the Aid flow from UN agencies (US$) of Low & middle income in 1981 to that in 1983?
Your answer should be compact. 0.86. What is the ratio of the Aid flow from UN agencies (US$) in Indonesia in 1981 to that in 1983?
Give a very brief answer. 0.77. What is the ratio of the Aid flow from UN agencies (US$) of Mauritania in 1981 to that in 1983?
Provide a short and direct response. 0.58. What is the ratio of the Aid flow from UN agencies (US$) in Euro area in 1981 to that in 1984?
Offer a terse response. 7. What is the ratio of the Aid flow from UN agencies (US$) in Low & middle income in 1981 to that in 1984?
Provide a short and direct response. 0.8. What is the ratio of the Aid flow from UN agencies (US$) of Indonesia in 1981 to that in 1984?
Your answer should be very brief. 1.22. What is the ratio of the Aid flow from UN agencies (US$) in Mauritania in 1981 to that in 1984?
Keep it short and to the point. 0.51. What is the ratio of the Aid flow from UN agencies (US$) of Euro area in 1982 to that in 1983?
Ensure brevity in your answer.  3.59. What is the ratio of the Aid flow from UN agencies (US$) in Low & middle income in 1982 to that in 1983?
Make the answer very short. 0.91. What is the ratio of the Aid flow from UN agencies (US$) of Indonesia in 1982 to that in 1983?
Your answer should be compact. 0.49. What is the ratio of the Aid flow from UN agencies (US$) of Mauritania in 1982 to that in 1983?
Your answer should be very brief. 0.39. What is the ratio of the Aid flow from UN agencies (US$) in Euro area in 1982 to that in 1984?
Your answer should be compact. 20.41. What is the ratio of the Aid flow from UN agencies (US$) in Low & middle income in 1982 to that in 1984?
Your answer should be very brief. 0.84. What is the ratio of the Aid flow from UN agencies (US$) of Indonesia in 1982 to that in 1984?
Provide a short and direct response. 0.78. What is the ratio of the Aid flow from UN agencies (US$) of Mauritania in 1982 to that in 1984?
Provide a succinct answer. 0.34. What is the ratio of the Aid flow from UN agencies (US$) in Euro area in 1983 to that in 1984?
Ensure brevity in your answer.  5.68. What is the ratio of the Aid flow from UN agencies (US$) in Low & middle income in 1983 to that in 1984?
Make the answer very short. 0.92. What is the ratio of the Aid flow from UN agencies (US$) of Indonesia in 1983 to that in 1984?
Your answer should be very brief. 1.59. What is the ratio of the Aid flow from UN agencies (US$) in Mauritania in 1983 to that in 1984?
Give a very brief answer. 0.87. What is the difference between the highest and the second highest Aid flow from UN agencies (US$) of Low & middle income?
Ensure brevity in your answer.  5.11e+07. What is the difference between the highest and the second highest Aid flow from UN agencies (US$) in Indonesia?
Your response must be concise. 3.68e+06. What is the difference between the highest and the second highest Aid flow from UN agencies (US$) in Mauritania?
Offer a very short reply. 1.09e+06. What is the difference between the highest and the lowest Aid flow from UN agencies (US$) in Euro area?
Provide a short and direct response. 4.40e+06. What is the difference between the highest and the lowest Aid flow from UN agencies (US$) in Low & middle income?
Offer a very short reply. 1.61e+08. What is the difference between the highest and the lowest Aid flow from UN agencies (US$) of Indonesia?
Ensure brevity in your answer.  1.14e+07. What is the difference between the highest and the lowest Aid flow from UN agencies (US$) of Mauritania?
Your answer should be compact. 5.55e+06. 